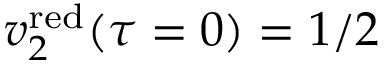Convert formula to latex. <formula><loc_0><loc_0><loc_500><loc_500>v _ { 2 } ^ { r e d } ( \tau = 0 ) = 1 / 2</formula> 